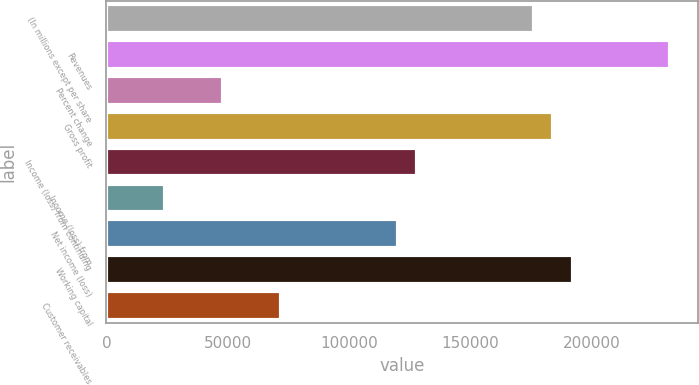Convert chart. <chart><loc_0><loc_0><loc_500><loc_500><bar_chart><fcel>(In millions except per share<fcel>Revenues<fcel>Percent change<fcel>Gross profit<fcel>Income (loss) from continuing<fcel>Income (loss) from<fcel>Net income (loss)<fcel>Working capital<fcel>Customer receivables<nl><fcel>176264<fcel>232348<fcel>48072.1<fcel>184276<fcel>128192<fcel>24036.2<fcel>120180<fcel>192288<fcel>72108.1<nl></chart> 